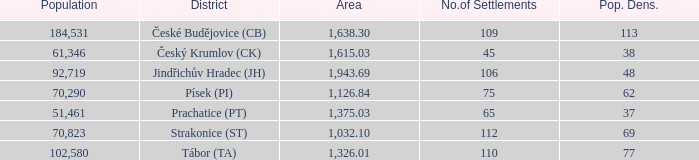Can you parse all the data within this table? {'header': ['Population', 'District', 'Area', 'No.of Settlements', 'Pop. Dens.'], 'rows': [['184,531', 'České Budějovice (CB)', '1,638.30', '109', '113'], ['61,346', 'Český Krumlov (CK)', '1,615.03', '45', '38'], ['92,719', 'Jindřichův Hradec (JH)', '1,943.69', '106', '48'], ['70,290', 'Písek (PI)', '1,126.84', '75', '62'], ['51,461', 'Prachatice (PT)', '1,375.03', '65', '37'], ['70,823', 'Strakonice (ST)', '1,032.10', '112', '69'], ['102,580', 'Tábor (TA)', '1,326.01', '110', '77']]} How many settlements are in český krumlov (ck) with a population density higher than 38? None. 